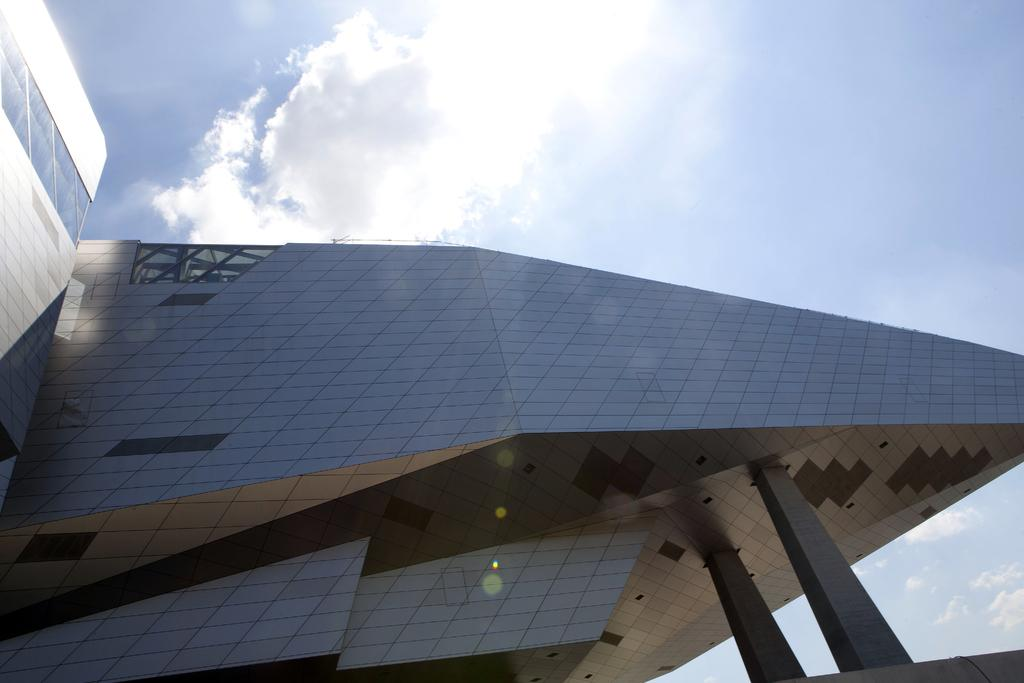What type of structure is present in the image? There is a building in the image. What can be seen in the background of the image? The sky is visible in the background of the image. How much money is being exchanged in the image? There is no indication of money or any financial transaction in the image. Can you describe the waves in the image? There are no waves present in the image; it features a building and the sky. 